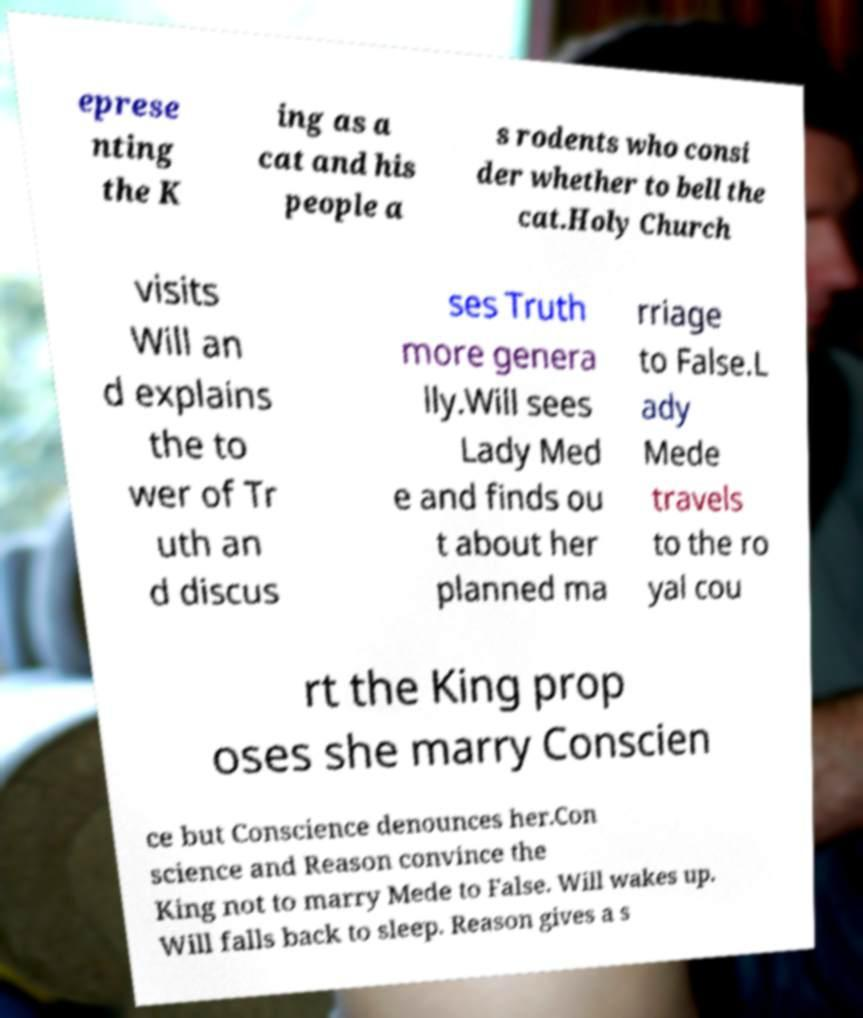I need the written content from this picture converted into text. Can you do that? eprese nting the K ing as a cat and his people a s rodents who consi der whether to bell the cat.Holy Church visits Will an d explains the to wer of Tr uth an d discus ses Truth more genera lly.Will sees Lady Med e and finds ou t about her planned ma rriage to False.L ady Mede travels to the ro yal cou rt the King prop oses she marry Conscien ce but Conscience denounces her.Con science and Reason convince the King not to marry Mede to False. Will wakes up. Will falls back to sleep. Reason gives a s 